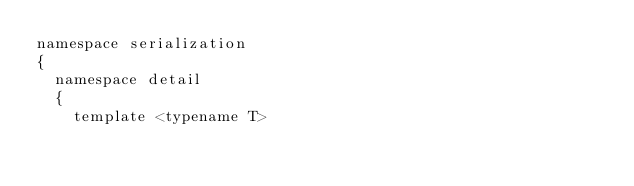Convert code to text. <code><loc_0><loc_0><loc_500><loc_500><_C_>namespace serialization
{
  namespace detail
  {
    template <typename T></code> 